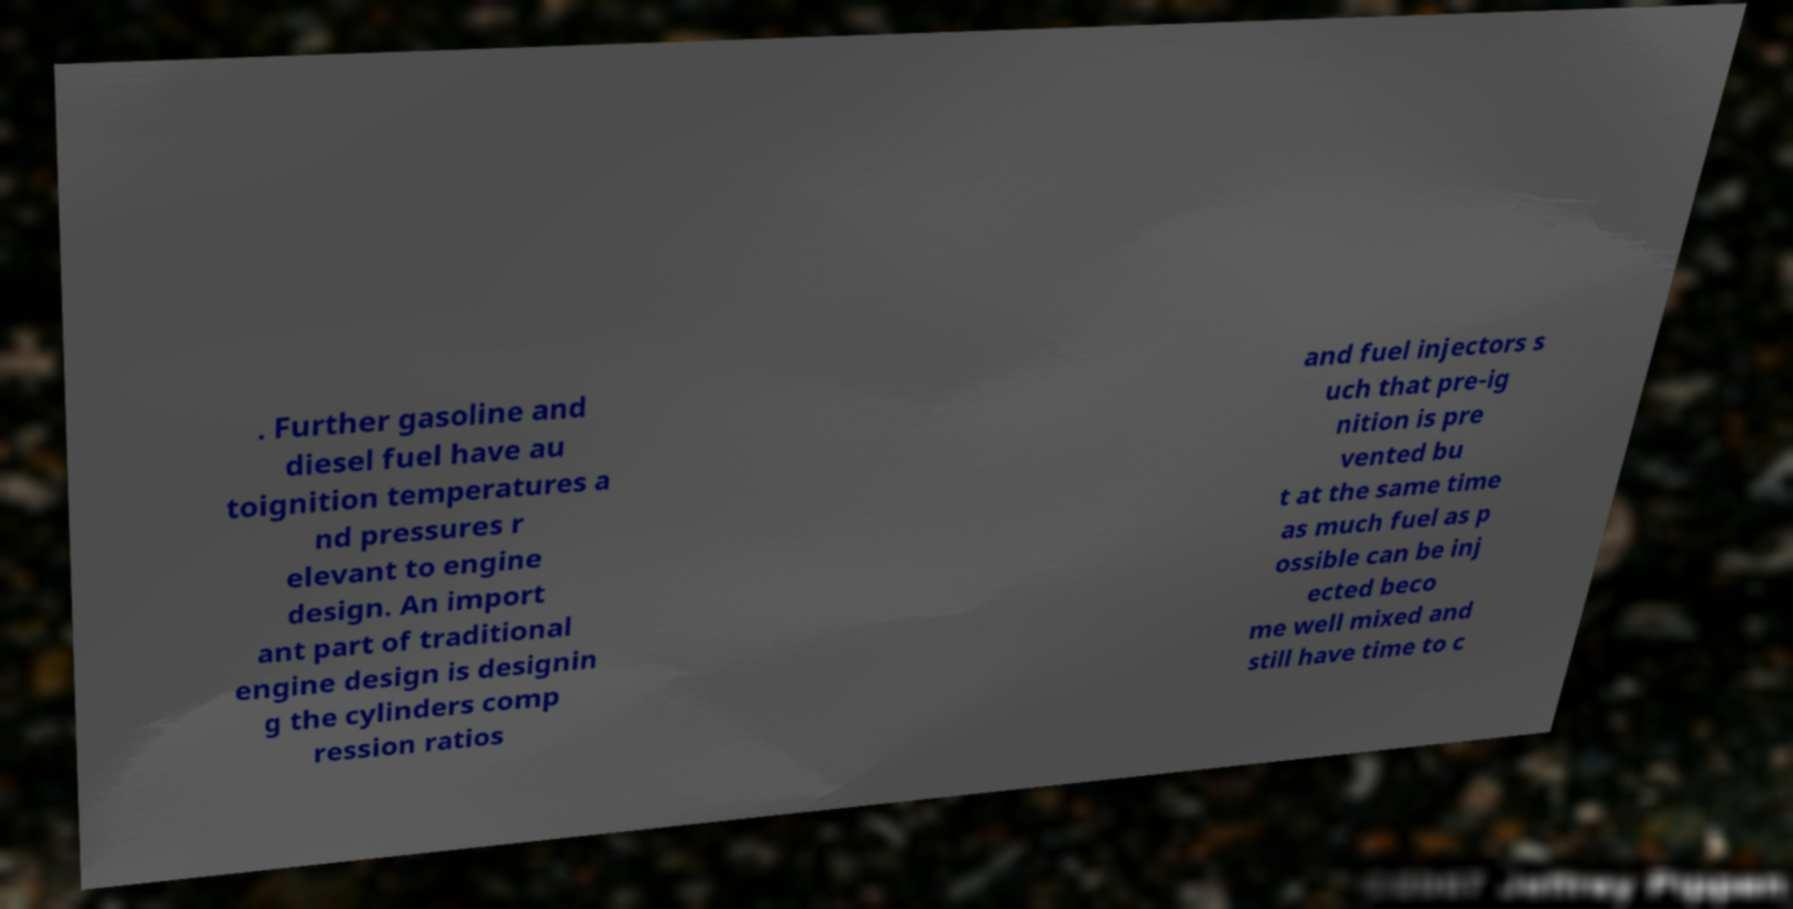Could you extract and type out the text from this image? . Further gasoline and diesel fuel have au toignition temperatures a nd pressures r elevant to engine design. An import ant part of traditional engine design is designin g the cylinders comp ression ratios and fuel injectors s uch that pre-ig nition is pre vented bu t at the same time as much fuel as p ossible can be inj ected beco me well mixed and still have time to c 